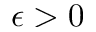<formula> <loc_0><loc_0><loc_500><loc_500>\epsilon > 0</formula> 